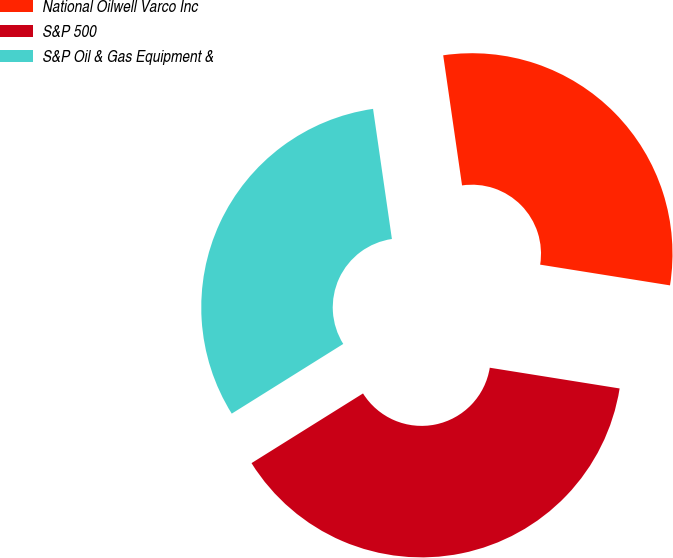<chart> <loc_0><loc_0><loc_500><loc_500><pie_chart><fcel>National Oilwell Varco Inc<fcel>S&P 500<fcel>S&P Oil & Gas Equipment &<nl><fcel>29.81%<fcel>38.59%<fcel>31.6%<nl></chart> 